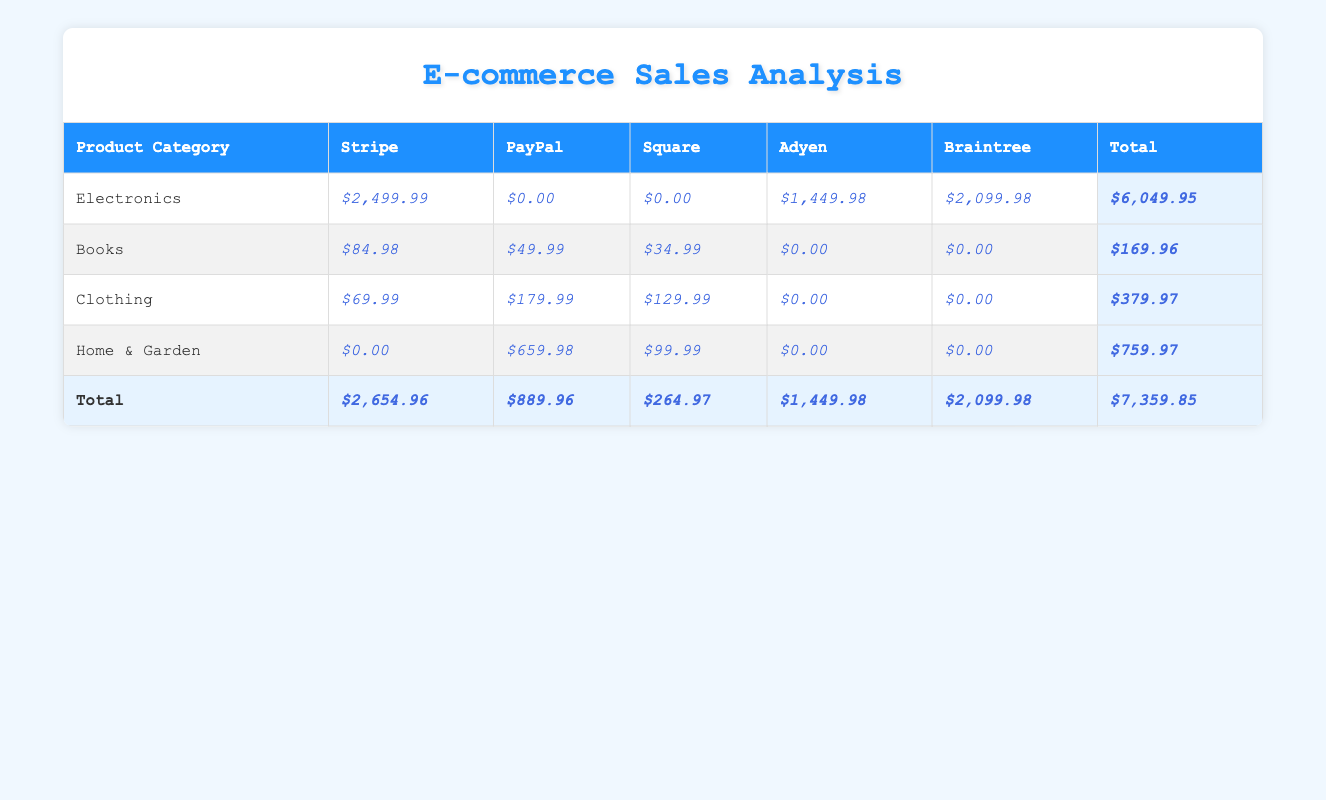What is the total sales amount for the Electronics category? The total sales amount for the Electronics category can be found in the table under the "Total" column for that row. It shows $6,049.95 as the sales amount for Electronics.
Answer: $6,049.95 Which payment gateway generated the highest sales in the Home & Garden category? Looking at the Home & Garden row, the payment amounts are $0.00 for Stripe, $659.98 for PayPal, $99.99 for Square, $0.00 for Adyen, and $0.00 for Braintree. The highest payment amount recorded is $659.98 from PayPal.
Answer: PayPal How much more did Clothing sales generate than Books sales? To find the difference, we first look at the total sales for Clothing, which is $379.97, and for Books, which is $169.96. The difference is calculated as $379.97 - $169.96 = $210.01.
Answer: $210.01 Is there any payment gateway that did not generate any sales for the Electronics category? Reviewing the payment amounts under the Electronics row, we see amounts for Stripe ($2,499.99), Adyen ($1,449.98), and Braintree ($2,099.98). However, there are no sales recorded for PayPal and Square, indicating that these gateways did not generate any sales for Electronics. Therefore, the answer is yes.
Answer: Yes What is the total sales amount for all product categories using PayPal? The total sales amount using PayPal can be found by summing the PayPal values from each category: from Books, $49.99; from Home & Garden, $659.98; from Clothing, $179.99. Thus, the total is calculated as $49.99 + $659.98 + $179.99 = $889.96. The table confirms this figure is shown under the total for PayPal.
Answer: $889.96 Which product category had the lowest total sales? Examining the total sales for each category, Electronics has $6,049.95, Books has $169.96, Clothing has $379.97, and Home & Garden has $759.97. The lowest total is $169.96, which corresponds to the Books category.
Answer: Books What percentage of total sales was made through Stripe? The total sales amount across all categories is $7,359.85, and Stripe generated $2,654.96 in sales. To find the percentage, we use the formula: (2,654.96 / 7,359.85) * 100. This calculation results in approximately 36.1%.
Answer: 36.1% 